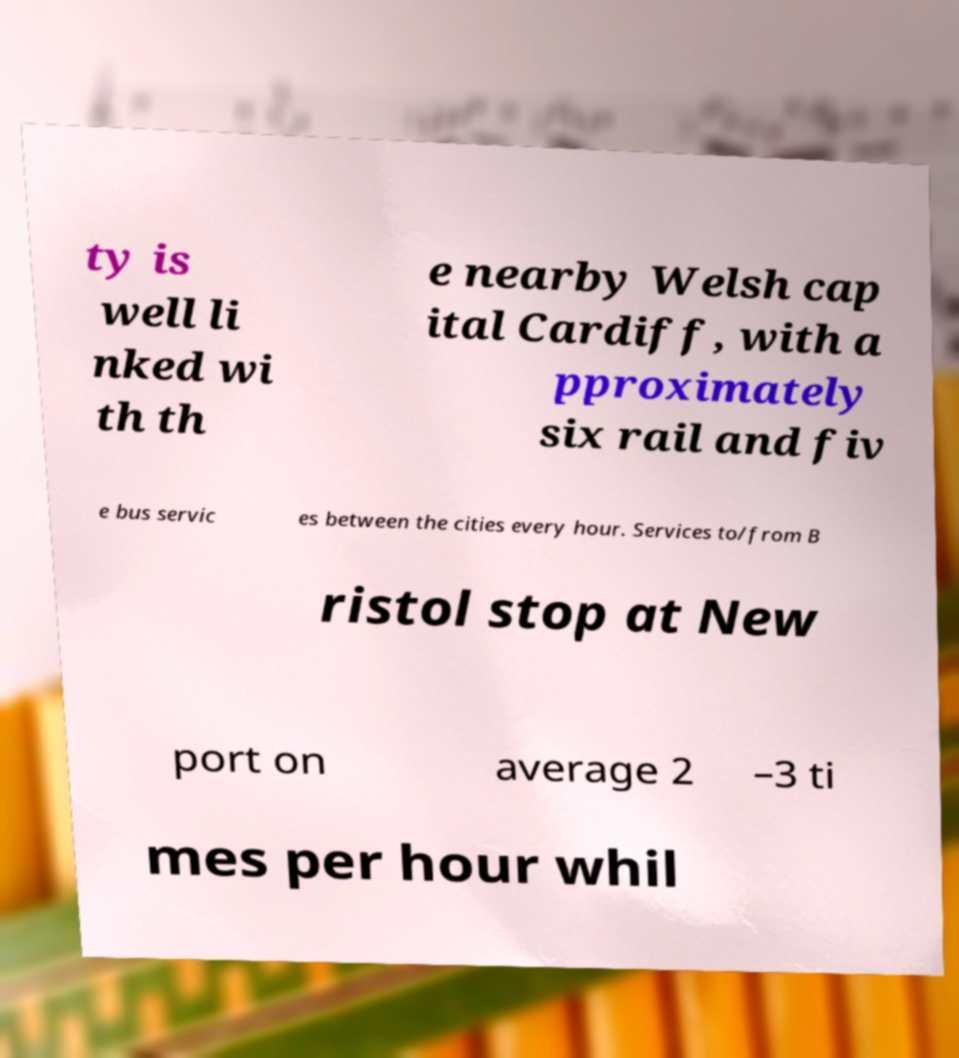I need the written content from this picture converted into text. Can you do that? ty is well li nked wi th th e nearby Welsh cap ital Cardiff, with a pproximately six rail and fiv e bus servic es between the cities every hour. Services to/from B ristol stop at New port on average 2 –3 ti mes per hour whil 